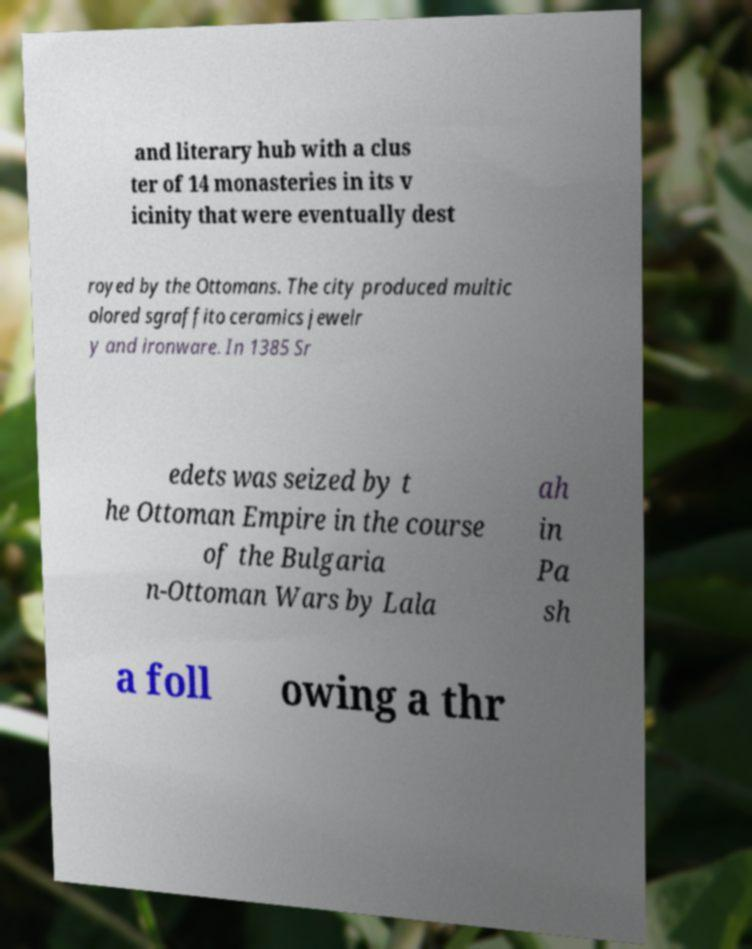What messages or text are displayed in this image? I need them in a readable, typed format. and literary hub with a clus ter of 14 monasteries in its v icinity that were eventually dest royed by the Ottomans. The city produced multic olored sgraffito ceramics jewelr y and ironware. In 1385 Sr edets was seized by t he Ottoman Empire in the course of the Bulgaria n-Ottoman Wars by Lala ah in Pa sh a foll owing a thr 